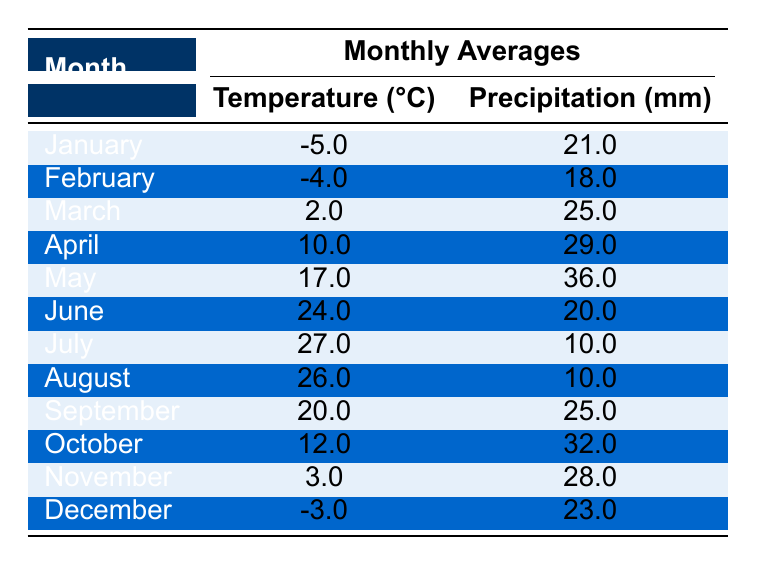What is the average temperature in Almaty for May? The temperature for May is 17.0°C, which is directly provided in the table under the monthly averages.
Answer: 17.0°C Which month had the highest precipitation? By looking at the precipitation values, May has the highest value at 36.0 mm, which is more than any other month's precipitation.
Answer: May What is the temperature difference between July and January? The temperature in July is 27.0°C and in January it is -5.0°C. Calculating the difference: 27.0 - (-5.0) = 27.0 + 5.0 = 32.0°C.
Answer: 32.0°C Was the temperature in February lower than in November? The temperature in February is -4.0°C and in November it is 3.0°C. Since -4.0°C is less than 3.0°C, the statement is true.
Answer: Yes What were the total precipitation values for the summer months (June, July, August)? The precipitation values for June, July, and August are 20.0 mm, 10.0 mm, and 10.0 mm respectively. Adding these values: 20.0 + 10.0 + 10.0 = 40.0 mm.
Answer: 40.0 mm How many months had a temperature above 20°C? The months with a temperature above 20°C are June (24.0°C), July (27.0°C), and August (26.0°C). Counting these months gives us 3.
Answer: 3 What is the average precipitation for the first half of the year (January to June)? The monthly precipitation values are: January 21.0 mm, February 18.0 mm, March 25.0 mm, April 29.0 mm, May 36.0 mm, and June 20.0 mm. Adding these values gives: 21.0 + 18.0 + 25.0 + 29.0 + 36.0 + 20.0 = 149.0 mm, and the average is 149.0 mm / 6 = 24.83 mm.
Answer: 24.83 mm Which month had the lowest temperature? By examining the table, January shows the lowest temperature, -5.0°C, which is lower than the temperatures in all other months.
Answer: January Did the total precipitation for the last quarter of the year exceed 100 mm? The precipitation values for October (32.0 mm), November (28.0 mm), and December (23.0 mm) total to 32.0 + 28.0 + 23.0 = 83.0 mm, which is less than 100 mm.
Answer: No In which month was the temperature closest to 0°C? The temperatures in January (-5.0°C) and March (2.0°C) are closest to 0°C. March at 2.0°C is the closest since it is above, while January is below.
Answer: March 